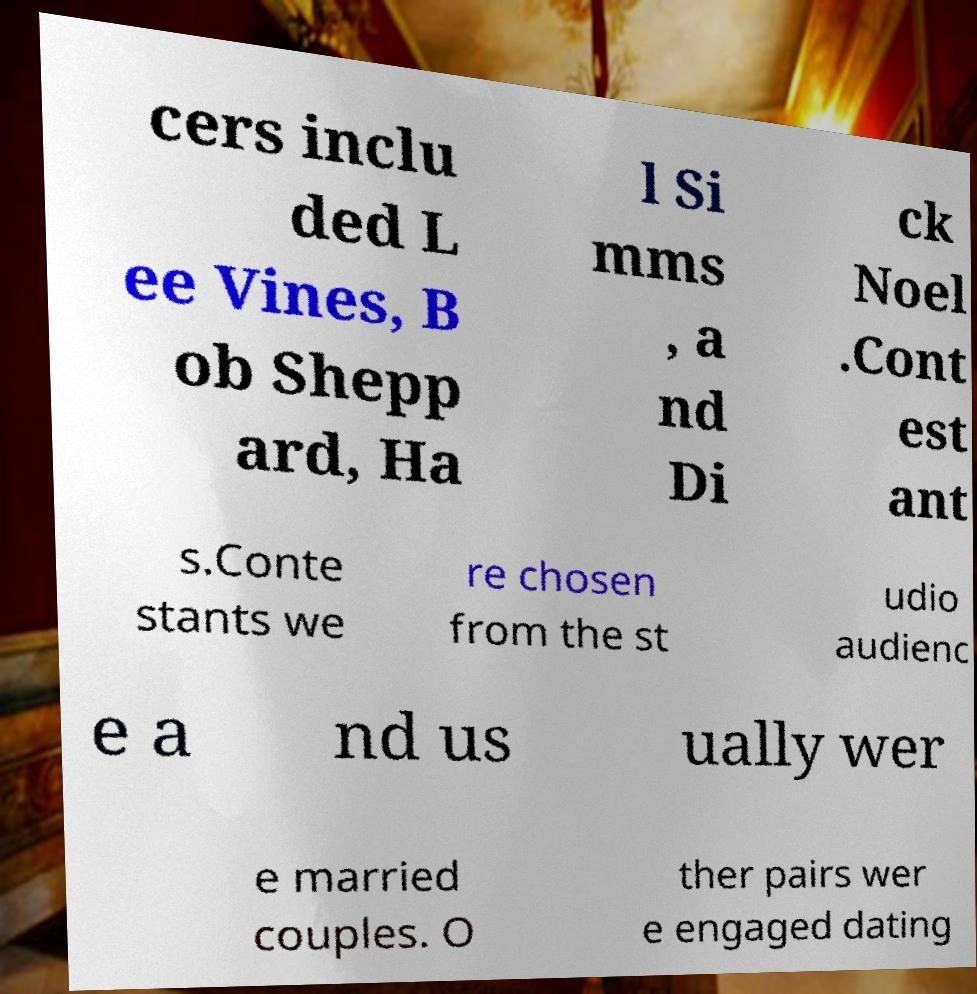For documentation purposes, I need the text within this image transcribed. Could you provide that? cers inclu ded L ee Vines, B ob Shepp ard, Ha l Si mms , a nd Di ck Noel .Cont est ant s.Conte stants we re chosen from the st udio audienc e a nd us ually wer e married couples. O ther pairs wer e engaged dating 